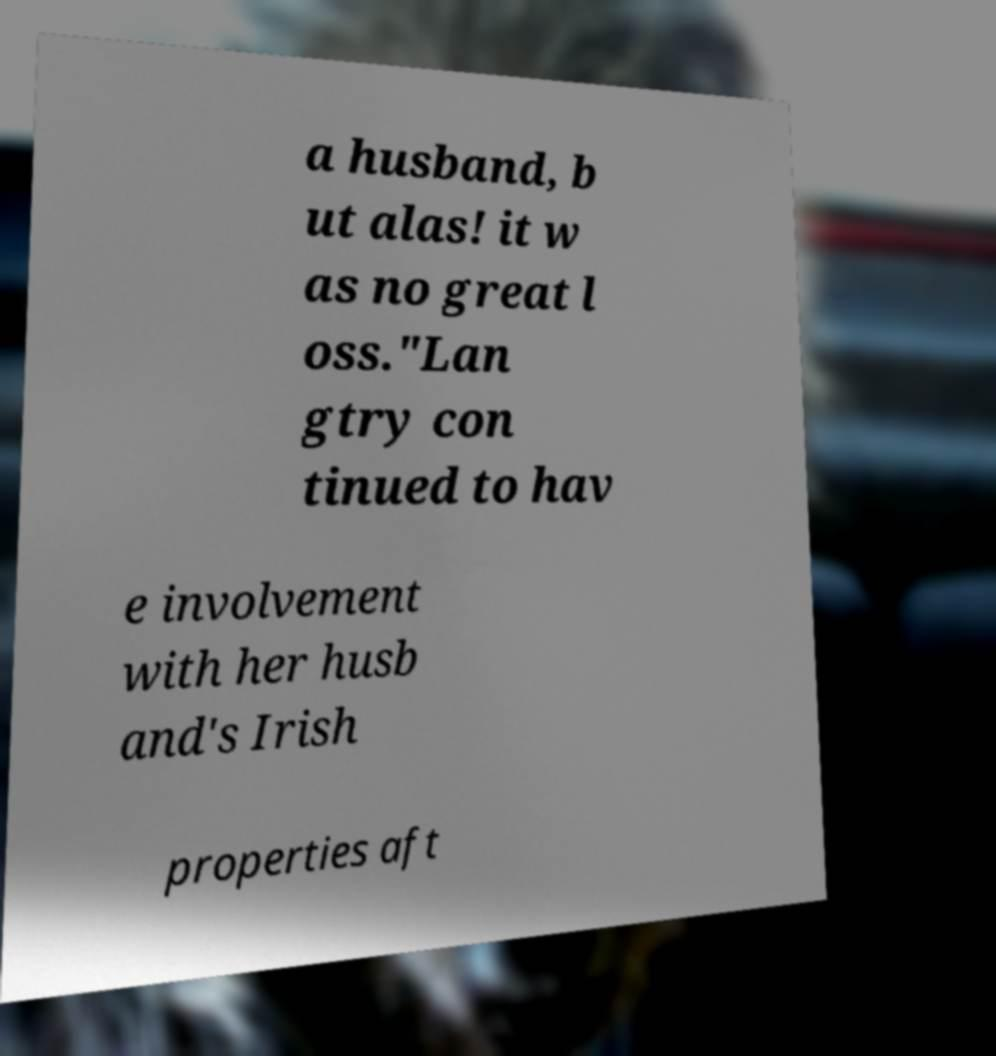Please read and relay the text visible in this image. What does it say? a husband, b ut alas! it w as no great l oss."Lan gtry con tinued to hav e involvement with her husb and's Irish properties aft 